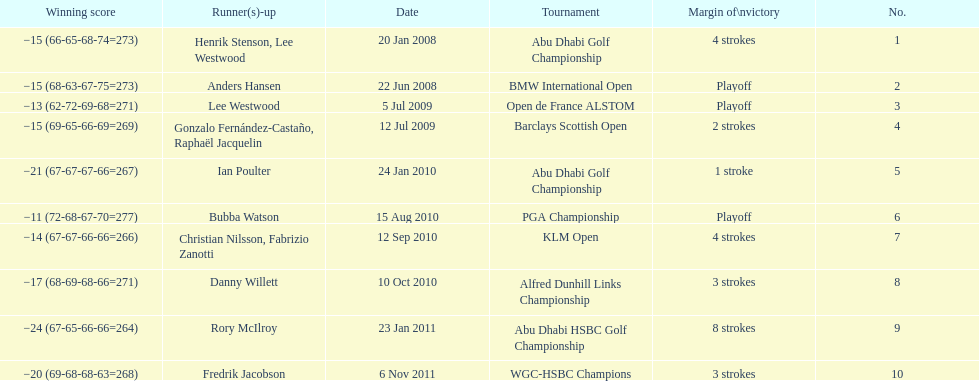Who had the top score in the pga championship? Bubba Watson. 